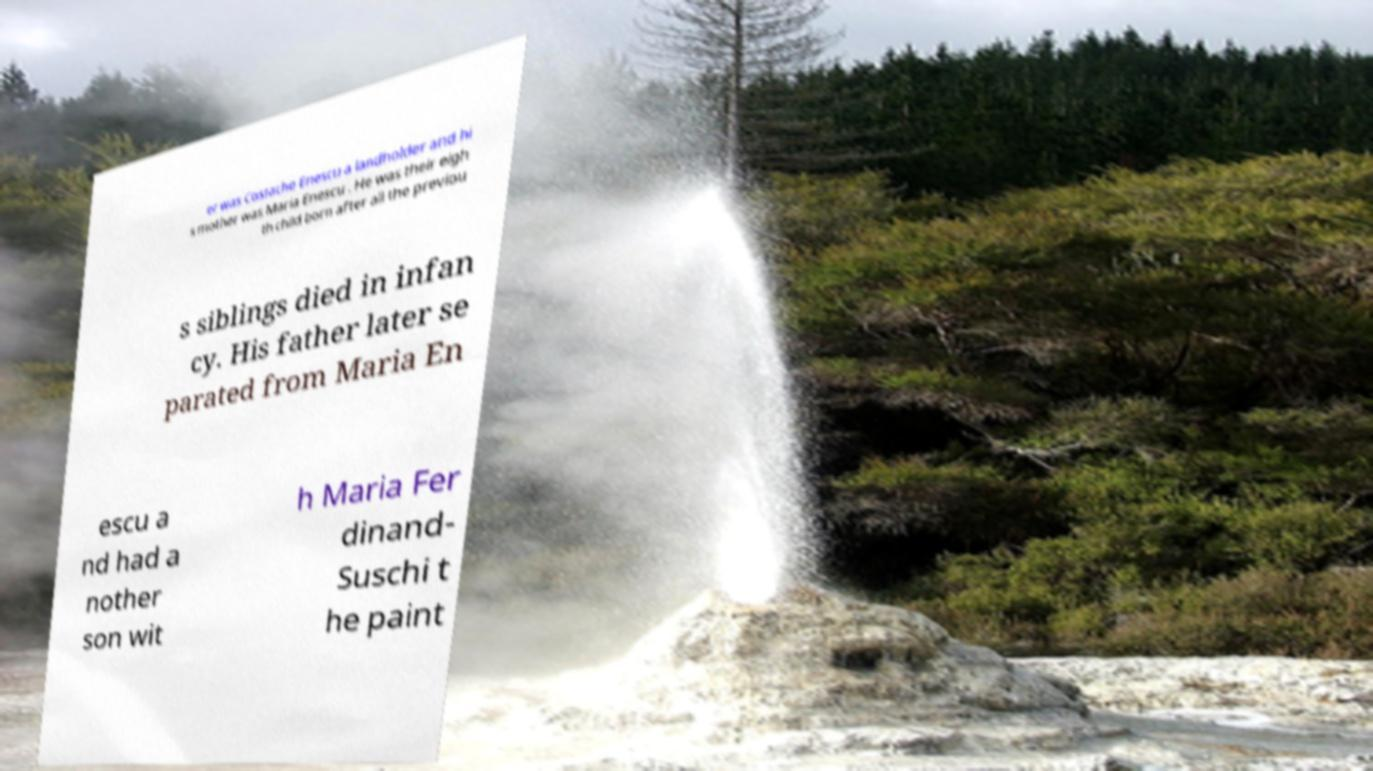Could you extract and type out the text from this image? er was Costache Enescu a landholder and hi s mother was Maria Enescu . He was their eigh th child born after all the previou s siblings died in infan cy. His father later se parated from Maria En escu a nd had a nother son wit h Maria Fer dinand- Suschi t he paint 